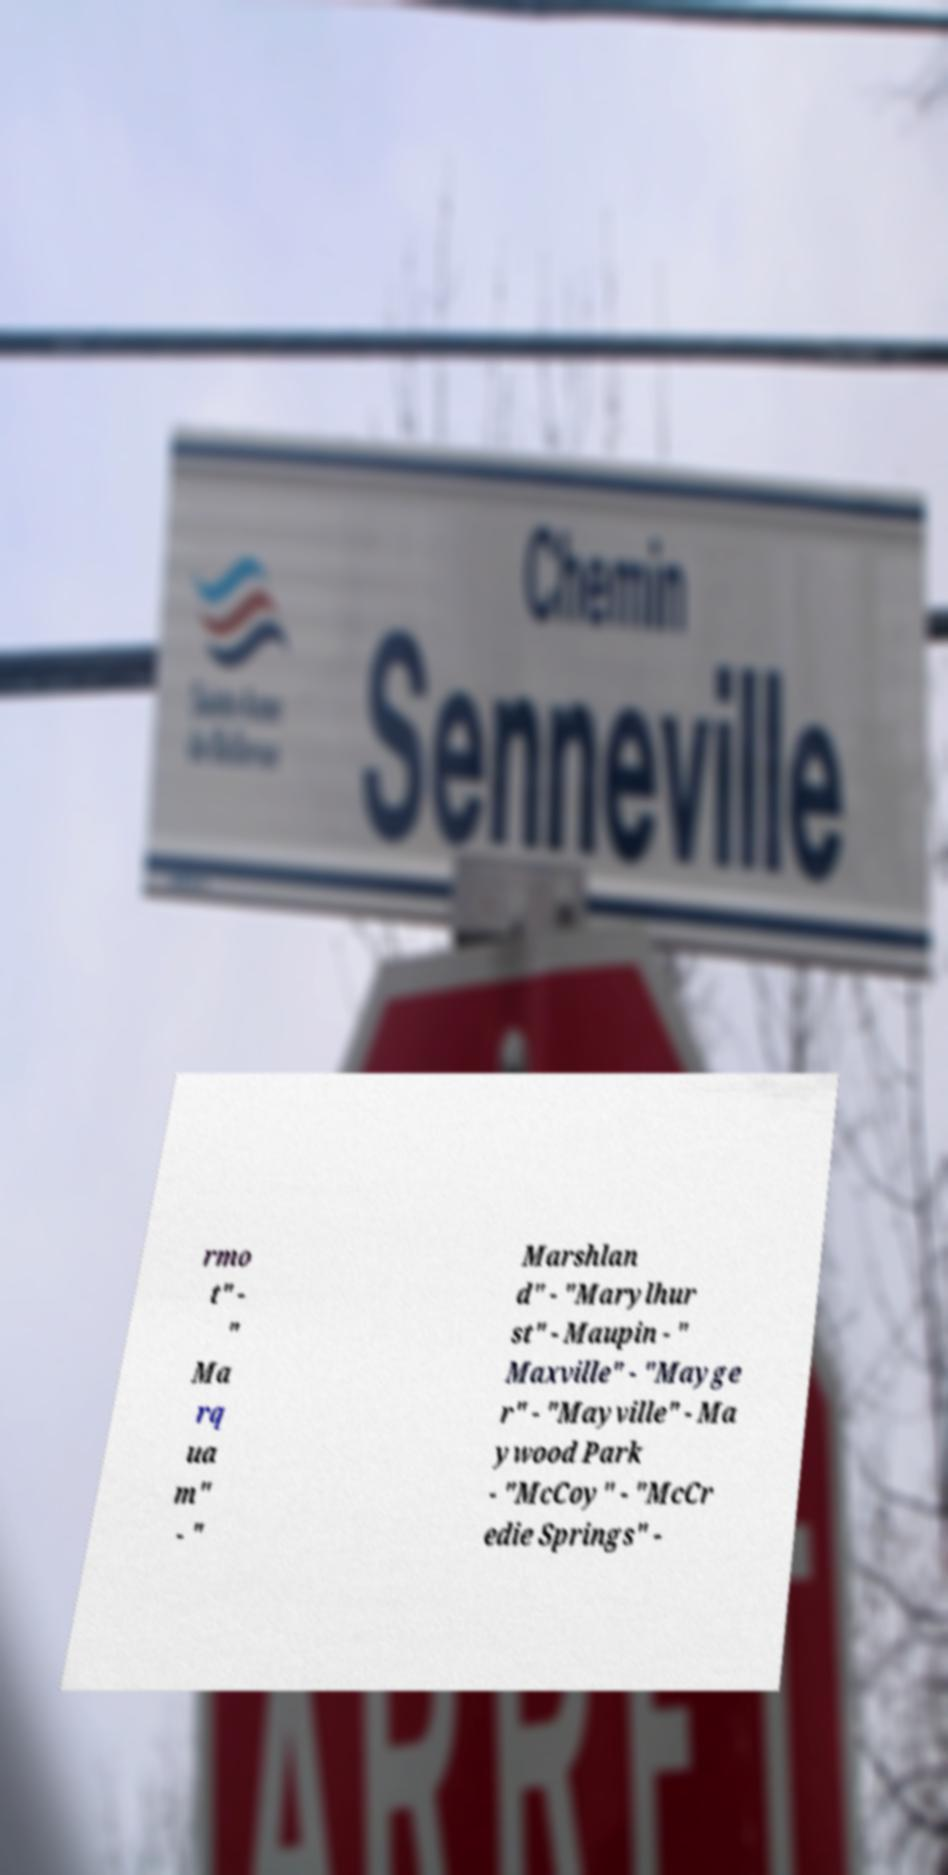Can you accurately transcribe the text from the provided image for me? rmo t" - " Ma rq ua m" - " Marshlan d" - "Marylhur st" - Maupin - " Maxville" - "Mayge r" - "Mayville" - Ma ywood Park - "McCoy" - "McCr edie Springs" - 